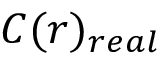Convert formula to latex. <formula><loc_0><loc_0><loc_500><loc_500>C ( r ) _ { r e a l }</formula> 